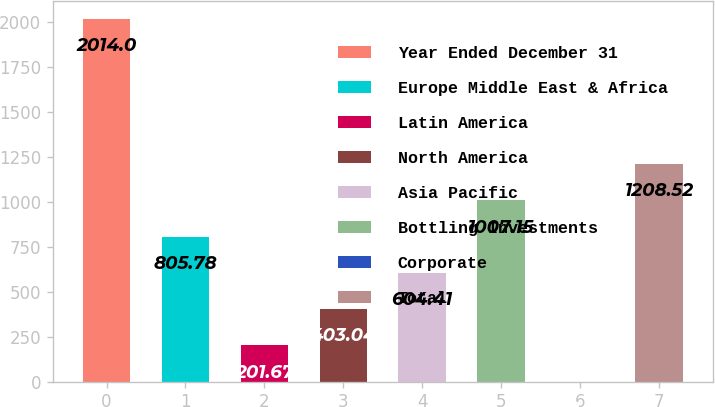Convert chart to OTSL. <chart><loc_0><loc_0><loc_500><loc_500><bar_chart><fcel>Year Ended December 31<fcel>Europe Middle East & Africa<fcel>Latin America<fcel>North America<fcel>Asia Pacific<fcel>Bottling Investments<fcel>Corporate<fcel>Total<nl><fcel>2014<fcel>805.78<fcel>201.67<fcel>403.04<fcel>604.41<fcel>1007.15<fcel>0.3<fcel>1208.52<nl></chart> 